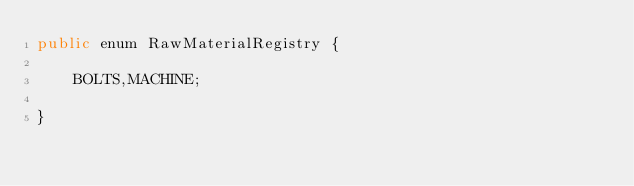<code> <loc_0><loc_0><loc_500><loc_500><_Java_>public enum RawMaterialRegistry {

	BOLTS,MACHINE;
	
}
</code> 